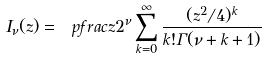Convert formula to latex. <formula><loc_0><loc_0><loc_500><loc_500>I _ { \nu } ( z ) = \ p f r a c z 2 ^ { \nu } \sum _ { k = 0 } ^ { \infty } \frac { ( z ^ { 2 } / 4 ) ^ { k } } { k ! \Gamma ( \nu + k + 1 ) }</formula> 